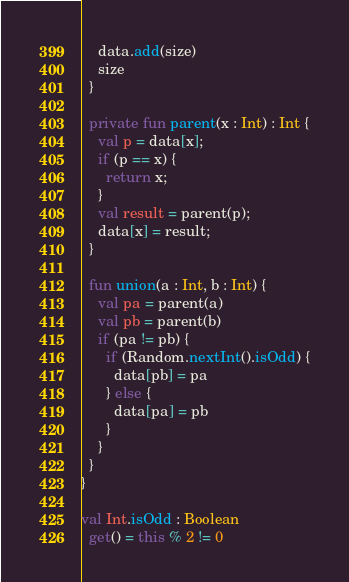Convert code to text. <code><loc_0><loc_0><loc_500><loc_500><_Kotlin_>    data.add(size)
    size
  }

  private fun parent(x : Int) : Int {
    val p = data[x];
    if (p == x) {
      return x;
    }
    val result = parent(p);
    data[x] = result;
  }

  fun union(a : Int, b : Int) {
    val pa = parent(a)
    val pb = parent(b)
    if (pa != pb) {
      if (Random.nextInt().isOdd) {
        data[pb] = pa
      } else {
        data[pa] = pb
      }
    }
  }
}

val Int.isOdd : Boolean
  get() = this % 2 != 0
</code> 